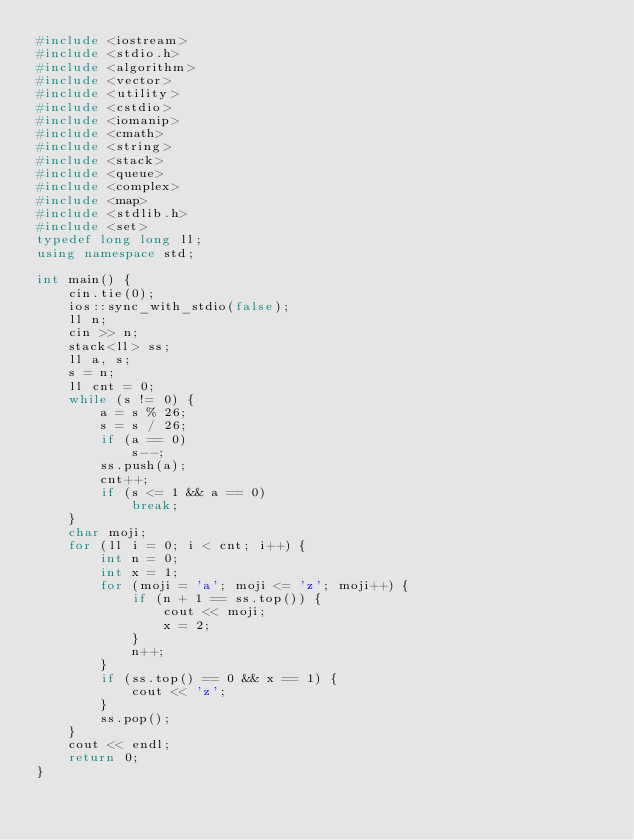<code> <loc_0><loc_0><loc_500><loc_500><_C++_>#include <iostream>
#include <stdio.h>
#include <algorithm>
#include <vector>
#include <utility>
#include <cstdio>
#include <iomanip>
#include <cmath>
#include <string>
#include <stack>
#include <queue>
#include <complex>
#include <map>
#include <stdlib.h>
#include <set>
typedef long long ll;
using namespace std;

int main() {
	cin.tie(0);
	ios::sync_with_stdio(false);
	ll n;
	cin >> n;
	stack<ll> ss;
	ll a, s;
	s = n;
	ll cnt = 0;
	while (s != 0) {
		a = s % 26;
		s = s / 26;
		if (a == 0)
			s--;
		ss.push(a);
		cnt++;
		if (s <= 1 && a == 0)
			break;
	}
	char moji;
	for (ll i = 0; i < cnt; i++) {
		int n = 0;
		int x = 1;
		for (moji = 'a'; moji <= 'z'; moji++) {
			if (n + 1 == ss.top()) {
				cout << moji;
				x = 2;
			}
			n++;
		}
		if (ss.top() == 0 && x == 1) {
			cout << 'z';
		}
		ss.pop();
	}
	cout << endl;
	return 0;
}
</code> 